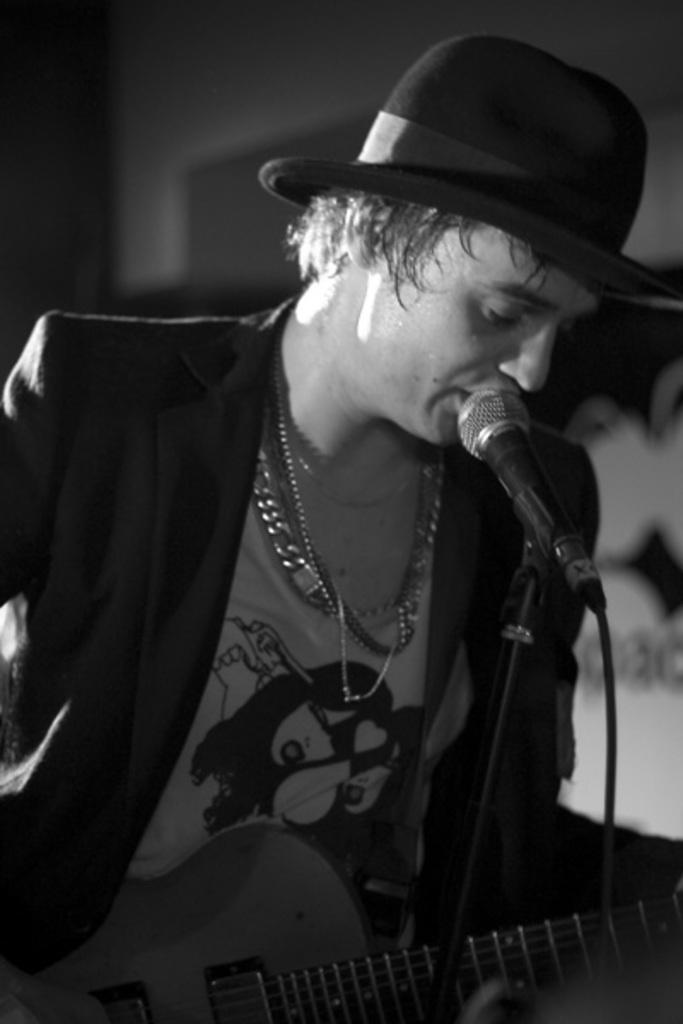Who is the main subject in the image? There is a man in the image. What is the man holding in the image? The man is holding a guitar. What object is in front of the man? There is a microphone in front of the man. What type of flowers can be seen growing around the man in the image? There are no flowers visible in the image; the focus is on the man holding a guitar and the microphone in front of him. 